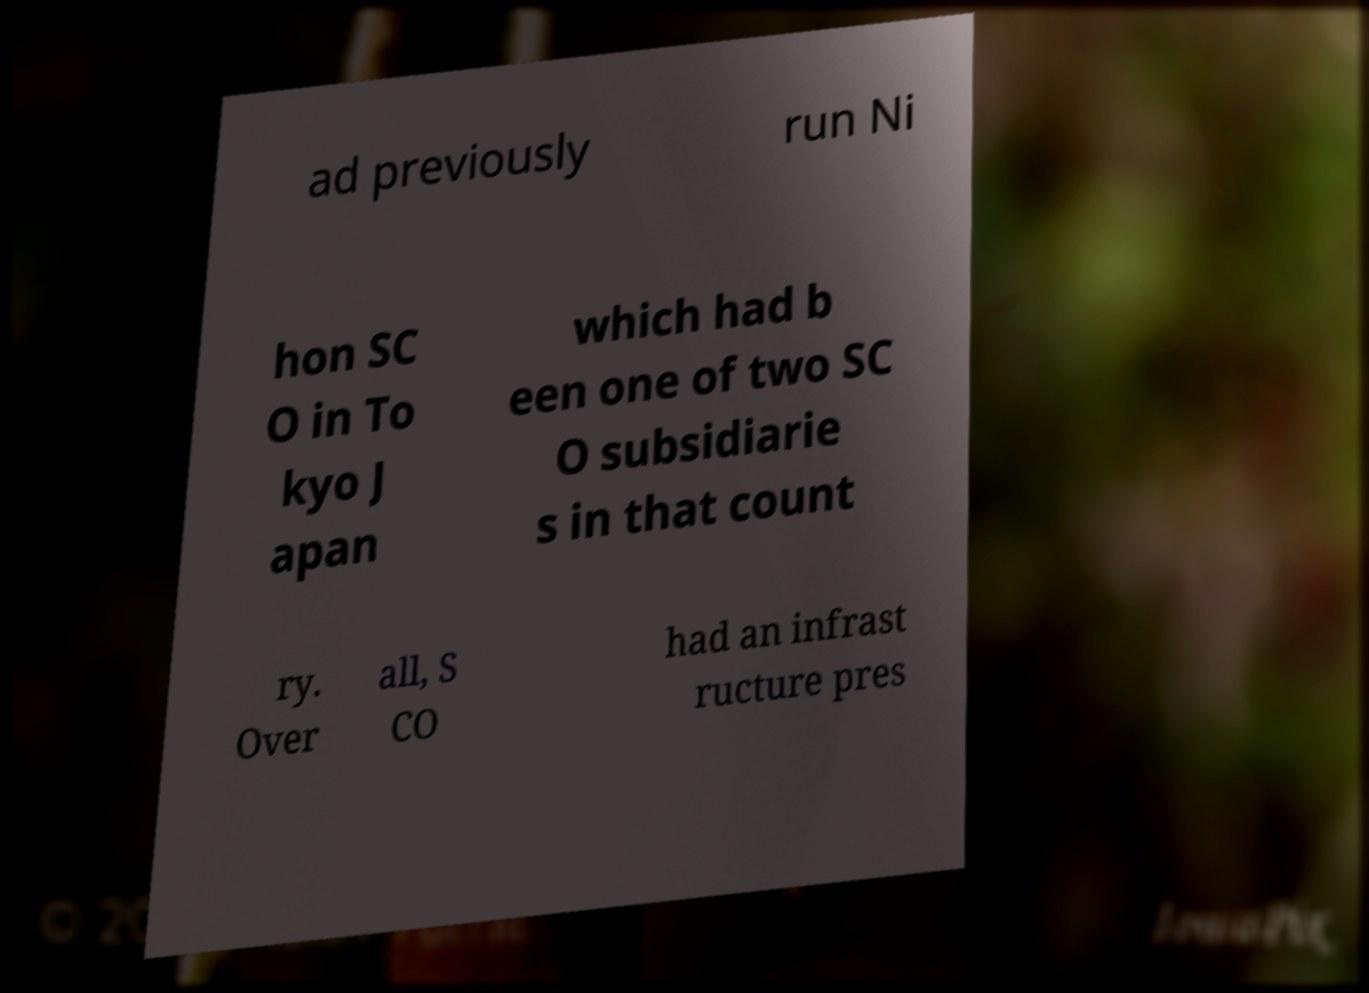Please identify and transcribe the text found in this image. ad previously run Ni hon SC O in To kyo J apan which had b een one of two SC O subsidiarie s in that count ry. Over all, S CO had an infrast ructure pres 